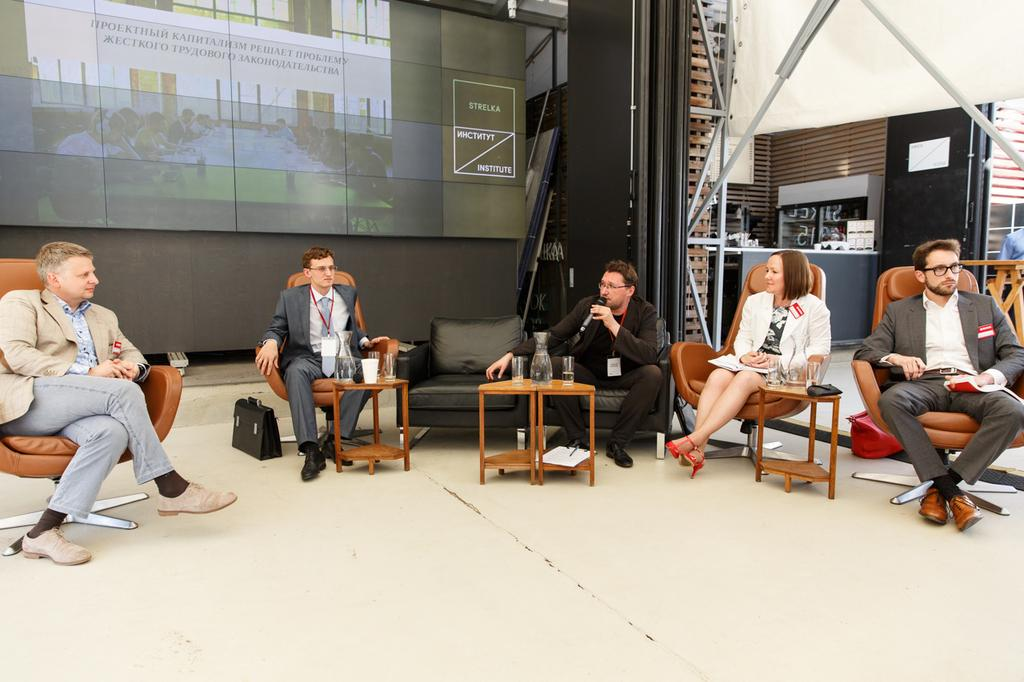What are the people in the image doing? There is a group of people sitting in the image. What is present in the image that they might be using? There is a table in the image that they might be using. What object can be seen on the floor in the image? There is a bag on the floor in the image. What can be seen in the background of the image? There is a board in the background of the image. Is there any snow visible in the image? No, there is no snow present in the image. Can you see any pockets on the people in the image? The image does not show the clothing of the people in enough detail to determine if they have pockets. 